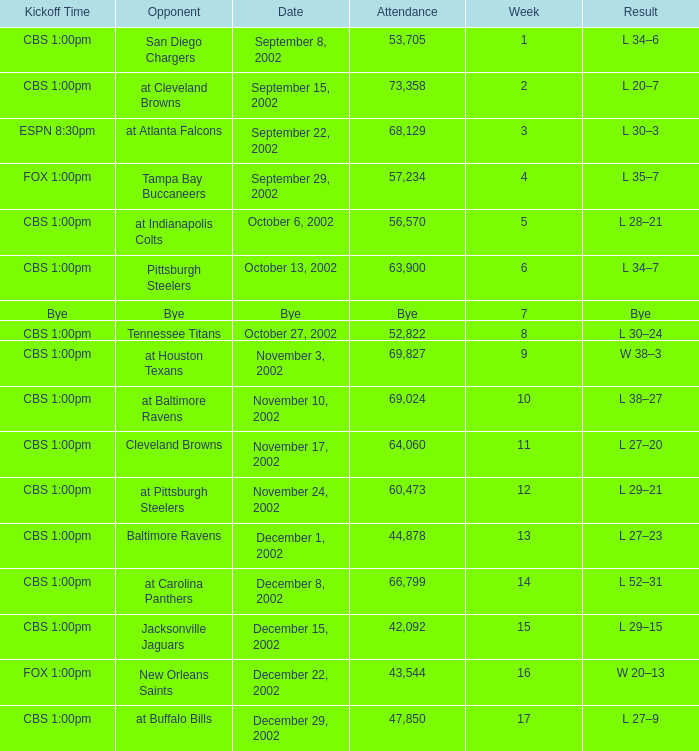Can you give me this table as a dict? {'header': ['Kickoff Time', 'Opponent', 'Date', 'Attendance', 'Week', 'Result'], 'rows': [['CBS 1:00pm', 'San Diego Chargers', 'September 8, 2002', '53,705', '1', 'L 34–6'], ['CBS 1:00pm', 'at Cleveland Browns', 'September 15, 2002', '73,358', '2', 'L 20–7'], ['ESPN 8:30pm', 'at Atlanta Falcons', 'September 22, 2002', '68,129', '3', 'L 30–3'], ['FOX 1:00pm', 'Tampa Bay Buccaneers', 'September 29, 2002', '57,234', '4', 'L 35–7'], ['CBS 1:00pm', 'at Indianapolis Colts', 'October 6, 2002', '56,570', '5', 'L 28–21'], ['CBS 1:00pm', 'Pittsburgh Steelers', 'October 13, 2002', '63,900', '6', 'L 34–7'], ['Bye', 'Bye', 'Bye', 'Bye', '7', 'Bye'], ['CBS 1:00pm', 'Tennessee Titans', 'October 27, 2002', '52,822', '8', 'L 30–24'], ['CBS 1:00pm', 'at Houston Texans', 'November 3, 2002', '69,827', '9', 'W 38–3'], ['CBS 1:00pm', 'at Baltimore Ravens', 'November 10, 2002', '69,024', '10', 'L 38–27'], ['CBS 1:00pm', 'Cleveland Browns', 'November 17, 2002', '64,060', '11', 'L 27–20'], ['CBS 1:00pm', 'at Pittsburgh Steelers', 'November 24, 2002', '60,473', '12', 'L 29–21'], ['CBS 1:00pm', 'Baltimore Ravens', 'December 1, 2002', '44,878', '13', 'L 27–23'], ['CBS 1:00pm', 'at Carolina Panthers', 'December 8, 2002', '66,799', '14', 'L 52–31'], ['CBS 1:00pm', 'Jacksonville Jaguars', 'December 15, 2002', '42,092', '15', 'L 29–15'], ['FOX 1:00pm', 'New Orleans Saints', 'December 22, 2002', '43,544', '16', 'W 20–13'], ['CBS 1:00pm', 'at Buffalo Bills', 'December 29, 2002', '47,850', '17', 'L 27–9']]} What week was the opponent the San Diego Chargers? 1.0. 